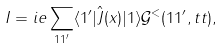Convert formula to latex. <formula><loc_0><loc_0><loc_500><loc_500>I = i e \sum _ { 1 1 ^ { \prime } } \langle 1 ^ { \prime } | \hat { J } ( x ) | 1 \rangle \mathcal { G } ^ { < } ( 1 1 ^ { \prime } , t t ) ,</formula> 